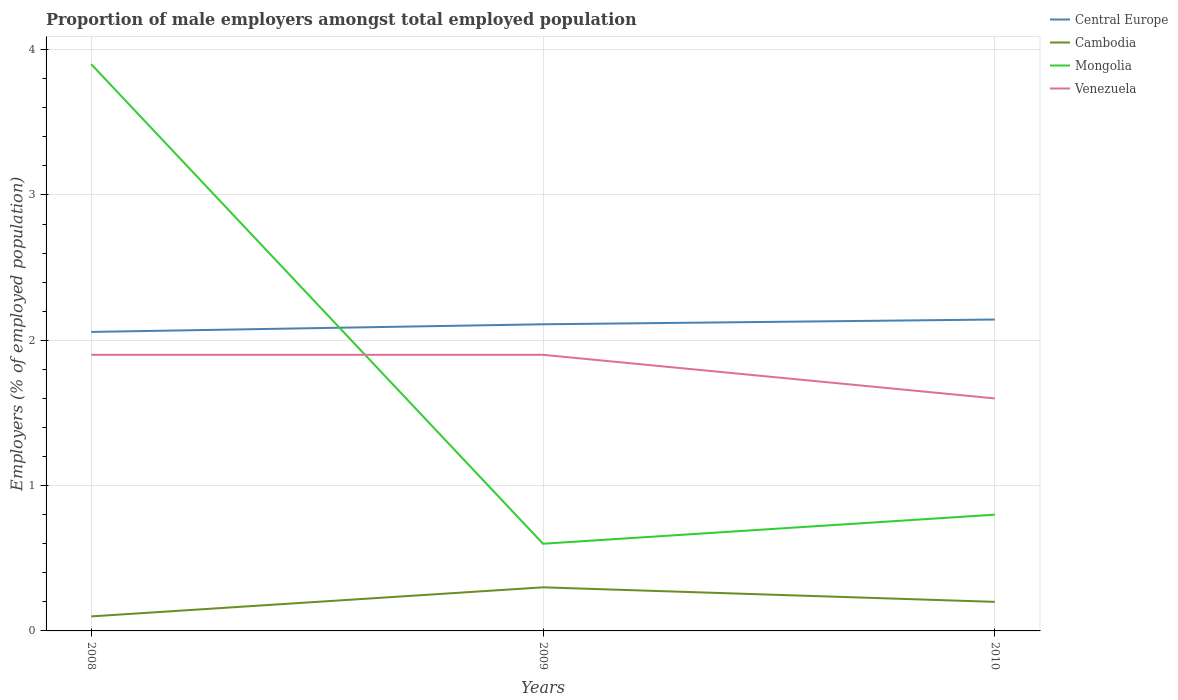Is the number of lines equal to the number of legend labels?
Ensure brevity in your answer.  Yes. Across all years, what is the maximum proportion of male employers in Cambodia?
Offer a terse response. 0.1. What is the total proportion of male employers in Venezuela in the graph?
Your answer should be compact. 0. What is the difference between the highest and the second highest proportion of male employers in Mongolia?
Provide a short and direct response. 3.3. What is the difference between the highest and the lowest proportion of male employers in Cambodia?
Offer a terse response. 1. Is the proportion of male employers in Central Europe strictly greater than the proportion of male employers in Cambodia over the years?
Offer a terse response. No. How many lines are there?
Make the answer very short. 4. What is the difference between two consecutive major ticks on the Y-axis?
Give a very brief answer. 1. Does the graph contain any zero values?
Your answer should be compact. No. How many legend labels are there?
Your answer should be very brief. 4. How are the legend labels stacked?
Ensure brevity in your answer.  Vertical. What is the title of the graph?
Offer a very short reply. Proportion of male employers amongst total employed population. What is the label or title of the X-axis?
Offer a terse response. Years. What is the label or title of the Y-axis?
Your response must be concise. Employers (% of employed population). What is the Employers (% of employed population) in Central Europe in 2008?
Your response must be concise. 2.06. What is the Employers (% of employed population) in Cambodia in 2008?
Make the answer very short. 0.1. What is the Employers (% of employed population) in Mongolia in 2008?
Offer a very short reply. 3.9. What is the Employers (% of employed population) in Venezuela in 2008?
Your response must be concise. 1.9. What is the Employers (% of employed population) in Central Europe in 2009?
Make the answer very short. 2.11. What is the Employers (% of employed population) of Cambodia in 2009?
Offer a terse response. 0.3. What is the Employers (% of employed population) in Mongolia in 2009?
Ensure brevity in your answer.  0.6. What is the Employers (% of employed population) of Venezuela in 2009?
Your answer should be compact. 1.9. What is the Employers (% of employed population) in Central Europe in 2010?
Give a very brief answer. 2.14. What is the Employers (% of employed population) of Cambodia in 2010?
Ensure brevity in your answer.  0.2. What is the Employers (% of employed population) in Mongolia in 2010?
Offer a terse response. 0.8. What is the Employers (% of employed population) in Venezuela in 2010?
Ensure brevity in your answer.  1.6. Across all years, what is the maximum Employers (% of employed population) of Central Europe?
Make the answer very short. 2.14. Across all years, what is the maximum Employers (% of employed population) in Cambodia?
Offer a terse response. 0.3. Across all years, what is the maximum Employers (% of employed population) of Mongolia?
Provide a succinct answer. 3.9. Across all years, what is the maximum Employers (% of employed population) of Venezuela?
Provide a succinct answer. 1.9. Across all years, what is the minimum Employers (% of employed population) of Central Europe?
Provide a succinct answer. 2.06. Across all years, what is the minimum Employers (% of employed population) in Cambodia?
Offer a terse response. 0.1. Across all years, what is the minimum Employers (% of employed population) of Mongolia?
Your response must be concise. 0.6. Across all years, what is the minimum Employers (% of employed population) of Venezuela?
Make the answer very short. 1.6. What is the total Employers (% of employed population) in Central Europe in the graph?
Your response must be concise. 6.31. What is the difference between the Employers (% of employed population) of Central Europe in 2008 and that in 2009?
Your answer should be very brief. -0.05. What is the difference between the Employers (% of employed population) of Mongolia in 2008 and that in 2009?
Your answer should be very brief. 3.3. What is the difference between the Employers (% of employed population) of Venezuela in 2008 and that in 2009?
Your answer should be very brief. 0. What is the difference between the Employers (% of employed population) of Central Europe in 2008 and that in 2010?
Your answer should be very brief. -0.09. What is the difference between the Employers (% of employed population) of Cambodia in 2008 and that in 2010?
Your answer should be compact. -0.1. What is the difference between the Employers (% of employed population) in Mongolia in 2008 and that in 2010?
Your answer should be compact. 3.1. What is the difference between the Employers (% of employed population) of Venezuela in 2008 and that in 2010?
Provide a succinct answer. 0.3. What is the difference between the Employers (% of employed population) in Central Europe in 2009 and that in 2010?
Provide a succinct answer. -0.03. What is the difference between the Employers (% of employed population) of Mongolia in 2009 and that in 2010?
Your response must be concise. -0.2. What is the difference between the Employers (% of employed population) in Central Europe in 2008 and the Employers (% of employed population) in Cambodia in 2009?
Provide a short and direct response. 1.76. What is the difference between the Employers (% of employed population) of Central Europe in 2008 and the Employers (% of employed population) of Mongolia in 2009?
Make the answer very short. 1.46. What is the difference between the Employers (% of employed population) in Central Europe in 2008 and the Employers (% of employed population) in Venezuela in 2009?
Your answer should be very brief. 0.16. What is the difference between the Employers (% of employed population) of Cambodia in 2008 and the Employers (% of employed population) of Mongolia in 2009?
Offer a very short reply. -0.5. What is the difference between the Employers (% of employed population) of Cambodia in 2008 and the Employers (% of employed population) of Venezuela in 2009?
Make the answer very short. -1.8. What is the difference between the Employers (% of employed population) in Central Europe in 2008 and the Employers (% of employed population) in Cambodia in 2010?
Give a very brief answer. 1.86. What is the difference between the Employers (% of employed population) of Central Europe in 2008 and the Employers (% of employed population) of Mongolia in 2010?
Offer a terse response. 1.26. What is the difference between the Employers (% of employed population) of Central Europe in 2008 and the Employers (% of employed population) of Venezuela in 2010?
Offer a very short reply. 0.46. What is the difference between the Employers (% of employed population) in Cambodia in 2008 and the Employers (% of employed population) in Mongolia in 2010?
Your response must be concise. -0.7. What is the difference between the Employers (% of employed population) in Cambodia in 2008 and the Employers (% of employed population) in Venezuela in 2010?
Your answer should be very brief. -1.5. What is the difference between the Employers (% of employed population) in Central Europe in 2009 and the Employers (% of employed population) in Cambodia in 2010?
Ensure brevity in your answer.  1.91. What is the difference between the Employers (% of employed population) in Central Europe in 2009 and the Employers (% of employed population) in Mongolia in 2010?
Your response must be concise. 1.31. What is the difference between the Employers (% of employed population) of Central Europe in 2009 and the Employers (% of employed population) of Venezuela in 2010?
Offer a terse response. 0.51. What is the difference between the Employers (% of employed population) of Cambodia in 2009 and the Employers (% of employed population) of Venezuela in 2010?
Your answer should be very brief. -1.3. What is the average Employers (% of employed population) in Central Europe per year?
Your answer should be compact. 2.1. What is the average Employers (% of employed population) of Cambodia per year?
Offer a terse response. 0.2. What is the average Employers (% of employed population) of Mongolia per year?
Make the answer very short. 1.77. What is the average Employers (% of employed population) of Venezuela per year?
Your response must be concise. 1.8. In the year 2008, what is the difference between the Employers (% of employed population) of Central Europe and Employers (% of employed population) of Cambodia?
Provide a succinct answer. 1.96. In the year 2008, what is the difference between the Employers (% of employed population) of Central Europe and Employers (% of employed population) of Mongolia?
Offer a very short reply. -1.84. In the year 2008, what is the difference between the Employers (% of employed population) in Central Europe and Employers (% of employed population) in Venezuela?
Your answer should be compact. 0.16. In the year 2008, what is the difference between the Employers (% of employed population) in Cambodia and Employers (% of employed population) in Venezuela?
Provide a succinct answer. -1.8. In the year 2009, what is the difference between the Employers (% of employed population) of Central Europe and Employers (% of employed population) of Cambodia?
Offer a very short reply. 1.81. In the year 2009, what is the difference between the Employers (% of employed population) in Central Europe and Employers (% of employed population) in Mongolia?
Offer a terse response. 1.51. In the year 2009, what is the difference between the Employers (% of employed population) of Central Europe and Employers (% of employed population) of Venezuela?
Offer a very short reply. 0.21. In the year 2009, what is the difference between the Employers (% of employed population) of Cambodia and Employers (% of employed population) of Venezuela?
Keep it short and to the point. -1.6. In the year 2009, what is the difference between the Employers (% of employed population) of Mongolia and Employers (% of employed population) of Venezuela?
Your response must be concise. -1.3. In the year 2010, what is the difference between the Employers (% of employed population) in Central Europe and Employers (% of employed population) in Cambodia?
Make the answer very short. 1.94. In the year 2010, what is the difference between the Employers (% of employed population) in Central Europe and Employers (% of employed population) in Mongolia?
Provide a short and direct response. 1.34. In the year 2010, what is the difference between the Employers (% of employed population) of Central Europe and Employers (% of employed population) of Venezuela?
Provide a short and direct response. 0.54. In the year 2010, what is the difference between the Employers (% of employed population) in Cambodia and Employers (% of employed population) in Venezuela?
Ensure brevity in your answer.  -1.4. In the year 2010, what is the difference between the Employers (% of employed population) of Mongolia and Employers (% of employed population) of Venezuela?
Your answer should be very brief. -0.8. What is the ratio of the Employers (% of employed population) of Central Europe in 2008 to that in 2009?
Keep it short and to the point. 0.98. What is the ratio of the Employers (% of employed population) in Cambodia in 2008 to that in 2009?
Make the answer very short. 0.33. What is the ratio of the Employers (% of employed population) of Venezuela in 2008 to that in 2009?
Give a very brief answer. 1. What is the ratio of the Employers (% of employed population) of Central Europe in 2008 to that in 2010?
Your response must be concise. 0.96. What is the ratio of the Employers (% of employed population) of Cambodia in 2008 to that in 2010?
Give a very brief answer. 0.5. What is the ratio of the Employers (% of employed population) in Mongolia in 2008 to that in 2010?
Give a very brief answer. 4.88. What is the ratio of the Employers (% of employed population) in Venezuela in 2008 to that in 2010?
Your response must be concise. 1.19. What is the ratio of the Employers (% of employed population) in Central Europe in 2009 to that in 2010?
Keep it short and to the point. 0.98. What is the ratio of the Employers (% of employed population) in Cambodia in 2009 to that in 2010?
Your response must be concise. 1.5. What is the ratio of the Employers (% of employed population) of Venezuela in 2009 to that in 2010?
Give a very brief answer. 1.19. What is the difference between the highest and the second highest Employers (% of employed population) of Central Europe?
Your response must be concise. 0.03. What is the difference between the highest and the second highest Employers (% of employed population) of Cambodia?
Give a very brief answer. 0.1. What is the difference between the highest and the second highest Employers (% of employed population) of Mongolia?
Make the answer very short. 3.1. What is the difference between the highest and the lowest Employers (% of employed population) in Central Europe?
Give a very brief answer. 0.09. What is the difference between the highest and the lowest Employers (% of employed population) in Cambodia?
Give a very brief answer. 0.2. 